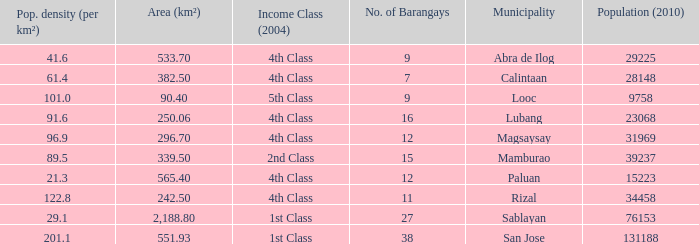What was the smallist population in 2010? 9758.0. Parse the table in full. {'header': ['Pop. density (per km²)', 'Area (km²)', 'Income Class (2004)', 'No. of Barangays', 'Municipality', 'Population (2010)'], 'rows': [['41.6', '533.70', '4th Class', '9', 'Abra de Ilog', '29225'], ['61.4', '382.50', '4th Class', '7', 'Calintaan', '28148'], ['101.0', '90.40', '5th Class', '9', 'Looc', '9758'], ['91.6', '250.06', '4th Class', '16', 'Lubang', '23068'], ['96.9', '296.70', '4th Class', '12', 'Magsaysay', '31969'], ['89.5', '339.50', '2nd Class', '15', 'Mamburao', '39237'], ['21.3', '565.40', '4th Class', '12', 'Paluan', '15223'], ['122.8', '242.50', '4th Class', '11', 'Rizal', '34458'], ['29.1', '2,188.80', '1st Class', '27', 'Sablayan', '76153'], ['201.1', '551.93', '1st Class', '38', 'San Jose', '131188']]} 